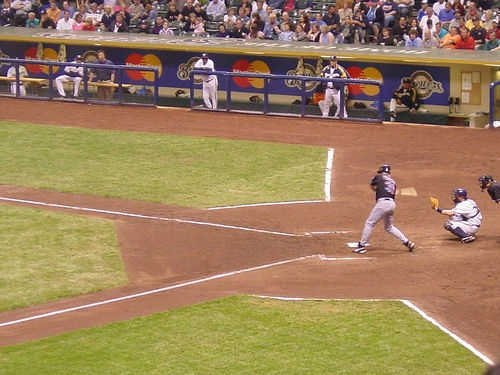Describe the objects in this image and their specific colors. I can see people in black, gray, and darkgray tones, people in black, lavender, brown, darkgray, and purple tones, people in black, lavender, darkgray, gray, and pink tones, people in black, darkgray, gray, lavender, and purple tones, and people in black, gray, purple, and maroon tones in this image. 